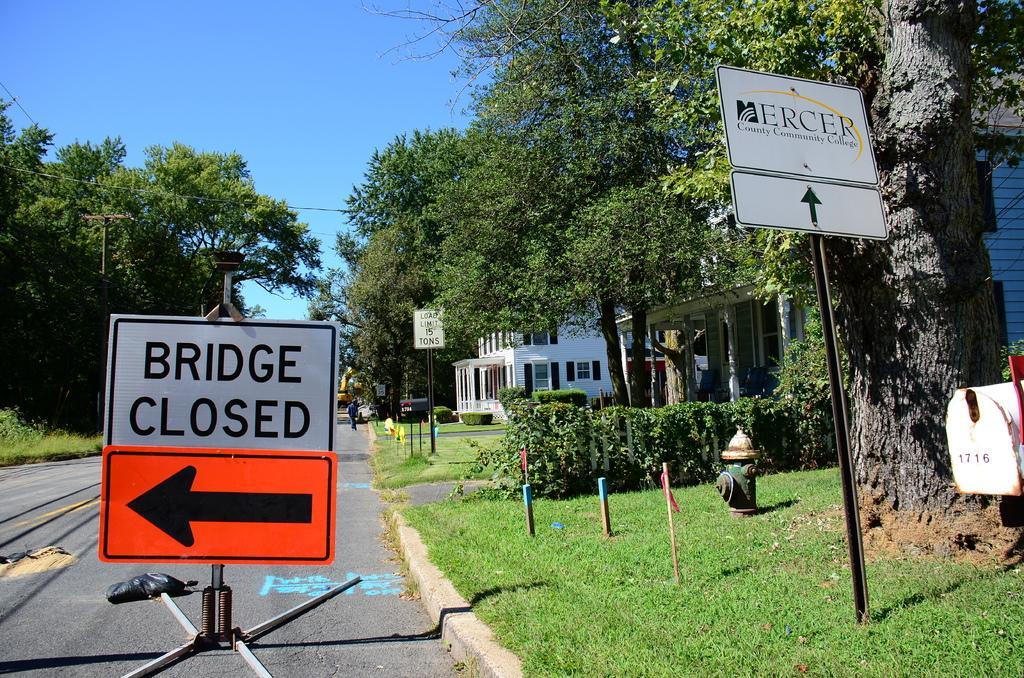Describe this image in one or two sentences. In this picture we can see name boards, direction boards, poles, grass, hydrant, plants, trees, buildings and a person on the road and some objects and in the background we can see the sky. 